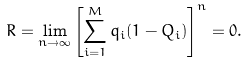<formula> <loc_0><loc_0><loc_500><loc_500>R = \lim _ { n \rightarrow \infty } \left [ \sum _ { i = 1 } ^ { M } q _ { i } ( 1 - Q _ { i } ) \right ] ^ { n } = 0 .</formula> 